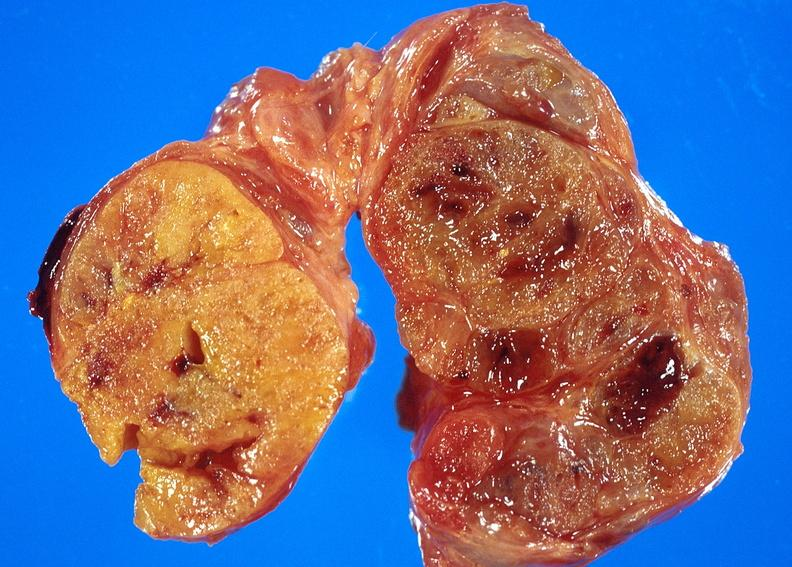s endocrine present?
Answer the question using a single word or phrase. Yes 